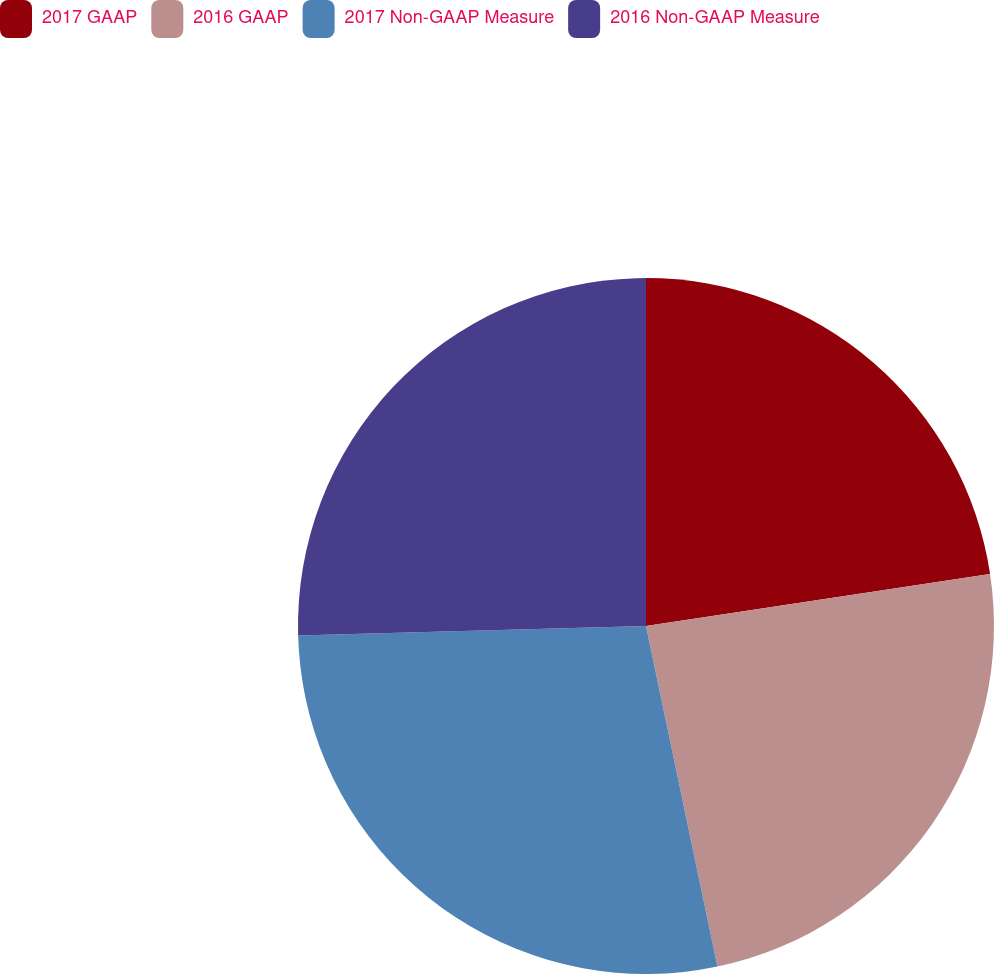Convert chart. <chart><loc_0><loc_0><loc_500><loc_500><pie_chart><fcel>2017 GAAP<fcel>2016 GAAP<fcel>2017 Non-GAAP Measure<fcel>2016 Non-GAAP Measure<nl><fcel>22.61%<fcel>24.1%<fcel>27.85%<fcel>25.44%<nl></chart> 